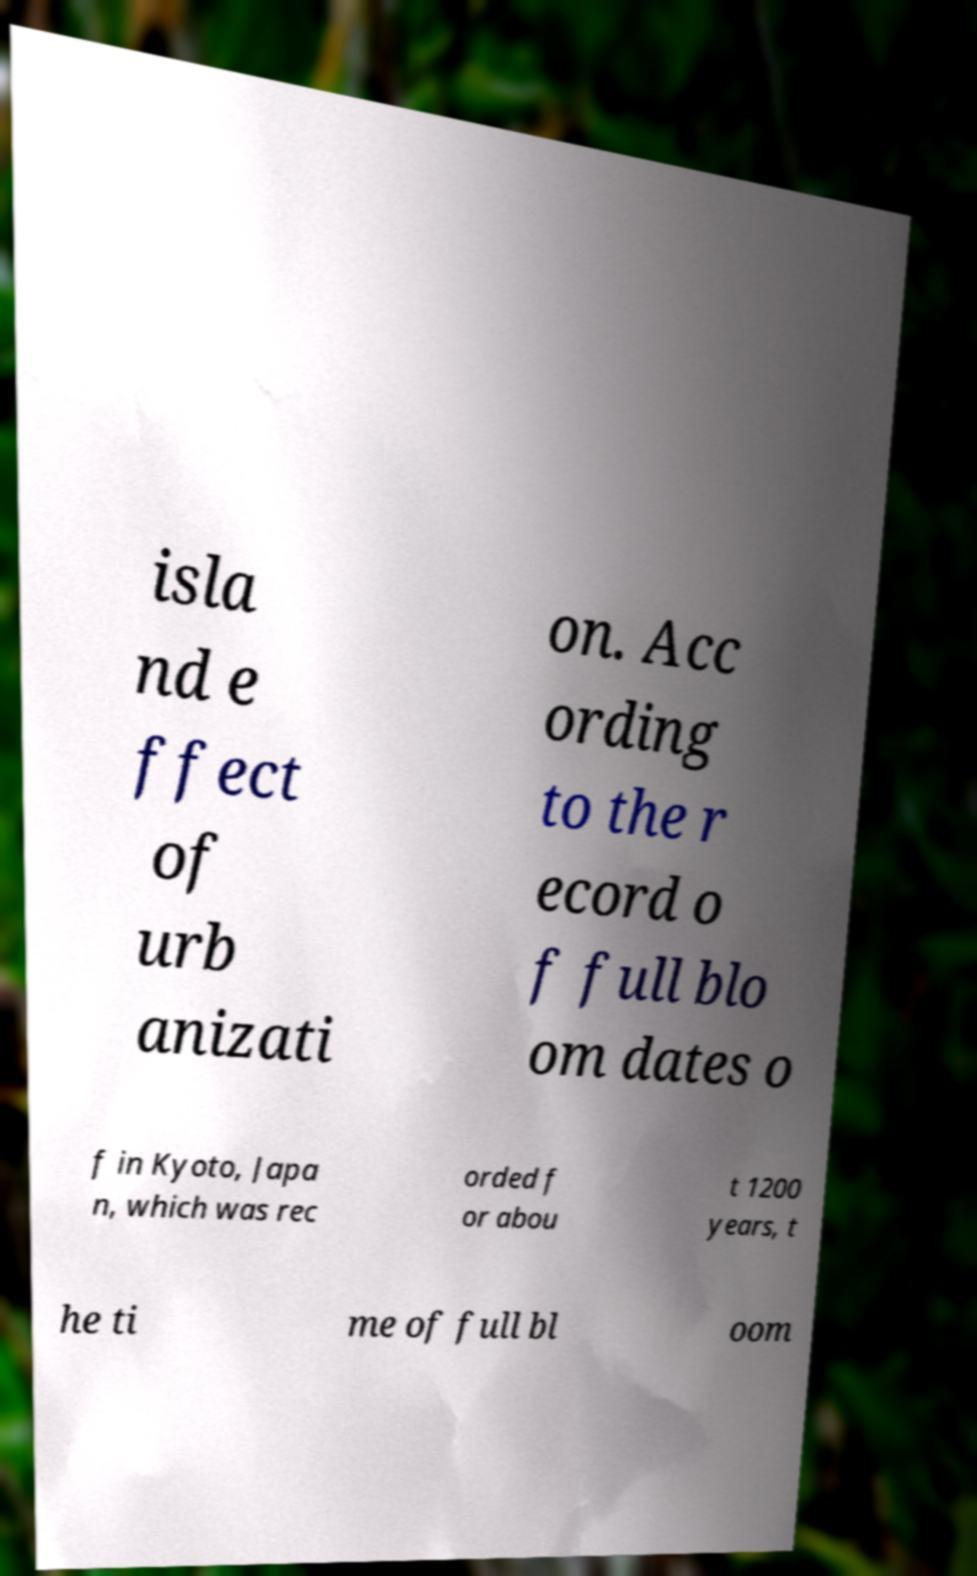Please identify and transcribe the text found in this image. isla nd e ffect of urb anizati on. Acc ording to the r ecord o f full blo om dates o f in Kyoto, Japa n, which was rec orded f or abou t 1200 years, t he ti me of full bl oom 